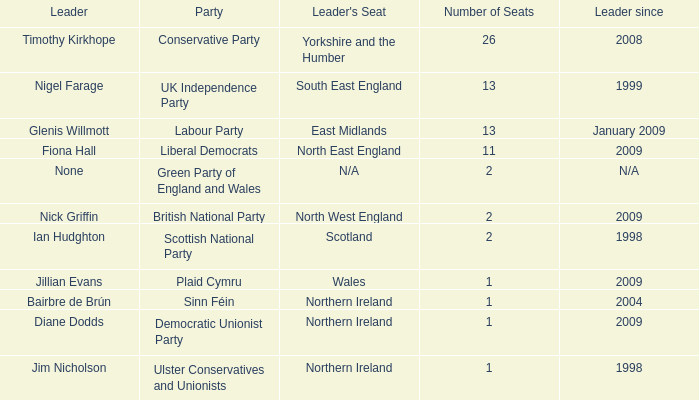Which party does Timothy Kirkhope lead? Conservative Party. 